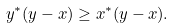Convert formula to latex. <formula><loc_0><loc_0><loc_500><loc_500>y ^ { * } ( y - x ) \geq x ^ { * } ( y - x ) .</formula> 